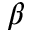Convert formula to latex. <formula><loc_0><loc_0><loc_500><loc_500>\beta</formula> 